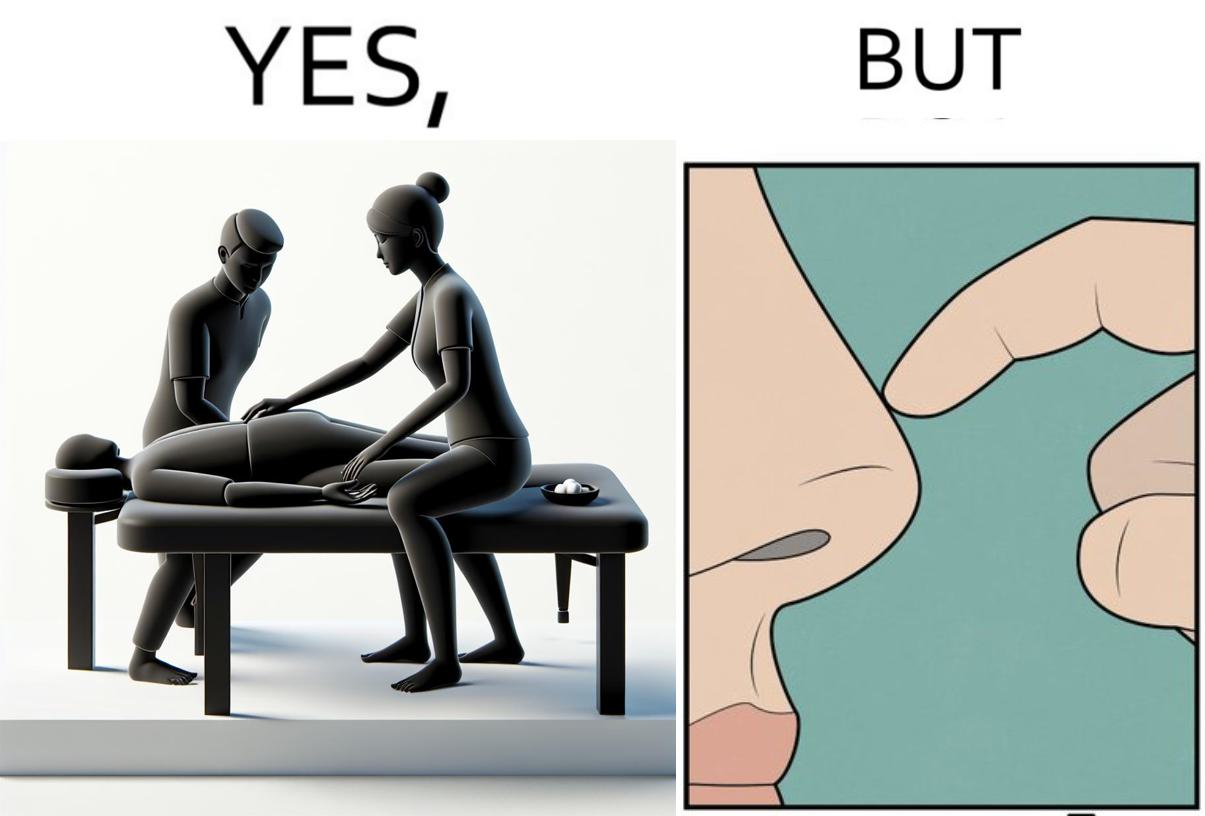Is there satirical content in this image? Yes, this image is satirical. 